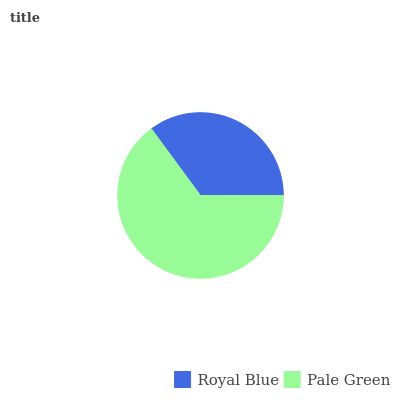Is Royal Blue the minimum?
Answer yes or no. Yes. Is Pale Green the maximum?
Answer yes or no. Yes. Is Pale Green the minimum?
Answer yes or no. No. Is Pale Green greater than Royal Blue?
Answer yes or no. Yes. Is Royal Blue less than Pale Green?
Answer yes or no. Yes. Is Royal Blue greater than Pale Green?
Answer yes or no. No. Is Pale Green less than Royal Blue?
Answer yes or no. No. Is Pale Green the high median?
Answer yes or no. Yes. Is Royal Blue the low median?
Answer yes or no. Yes. Is Royal Blue the high median?
Answer yes or no. No. Is Pale Green the low median?
Answer yes or no. No. 